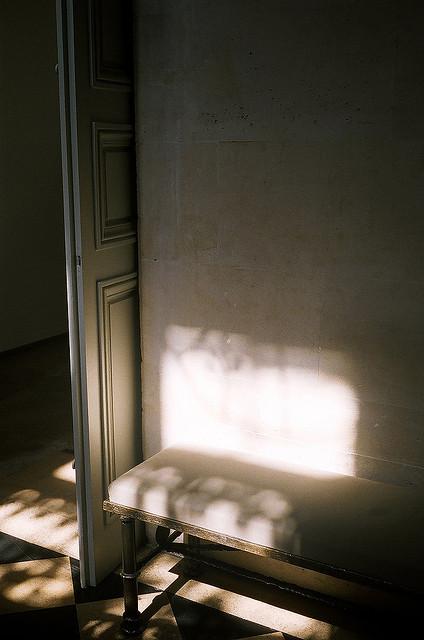What light source is causing the bright spot in this photograph?
Be succinct. Sun. Where is the hinged door?
Write a very short answer. Left. Is there a door in this room?
Concise answer only. Yes. 